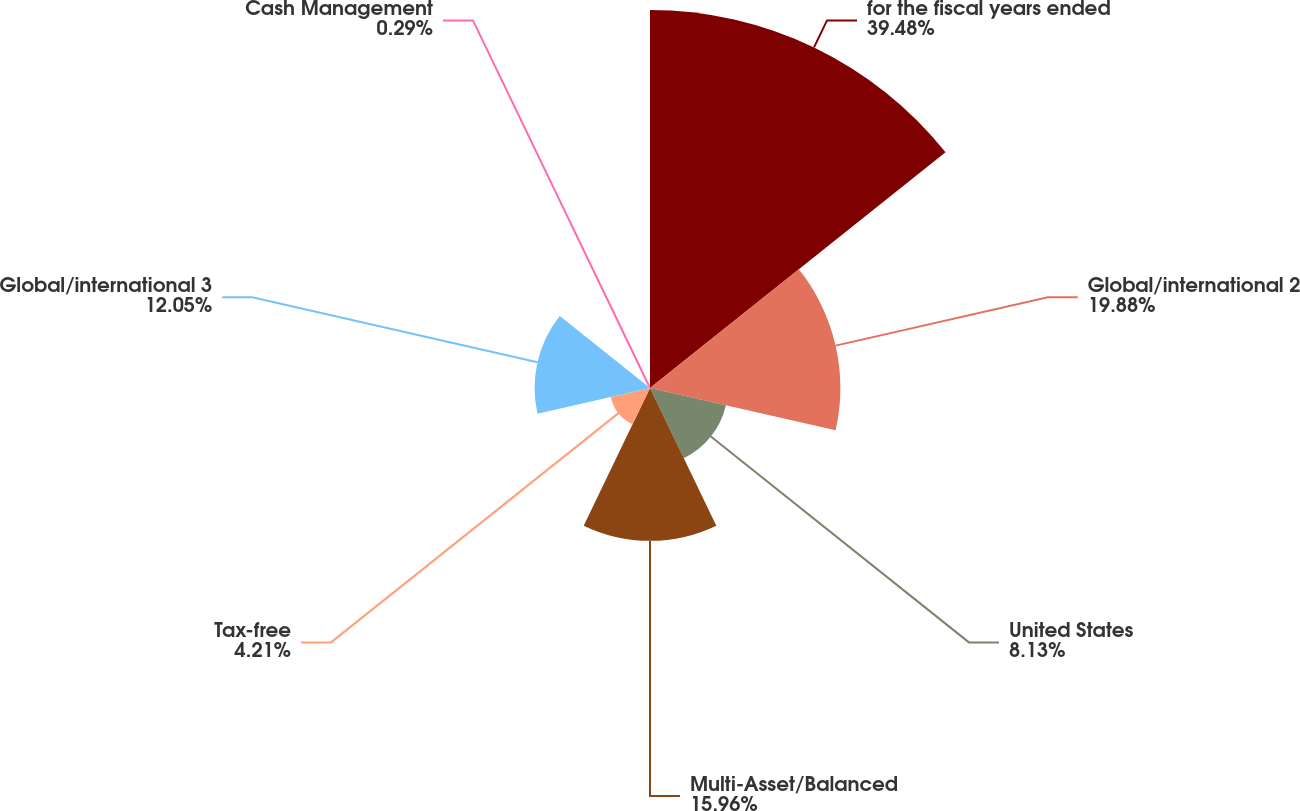Convert chart to OTSL. <chart><loc_0><loc_0><loc_500><loc_500><pie_chart><fcel>for the fiscal years ended<fcel>Global/international 2<fcel>United States<fcel>Multi-Asset/Balanced<fcel>Tax-free<fcel>Global/international 3<fcel>Cash Management<nl><fcel>39.47%<fcel>19.88%<fcel>8.13%<fcel>15.96%<fcel>4.21%<fcel>12.05%<fcel>0.29%<nl></chart> 